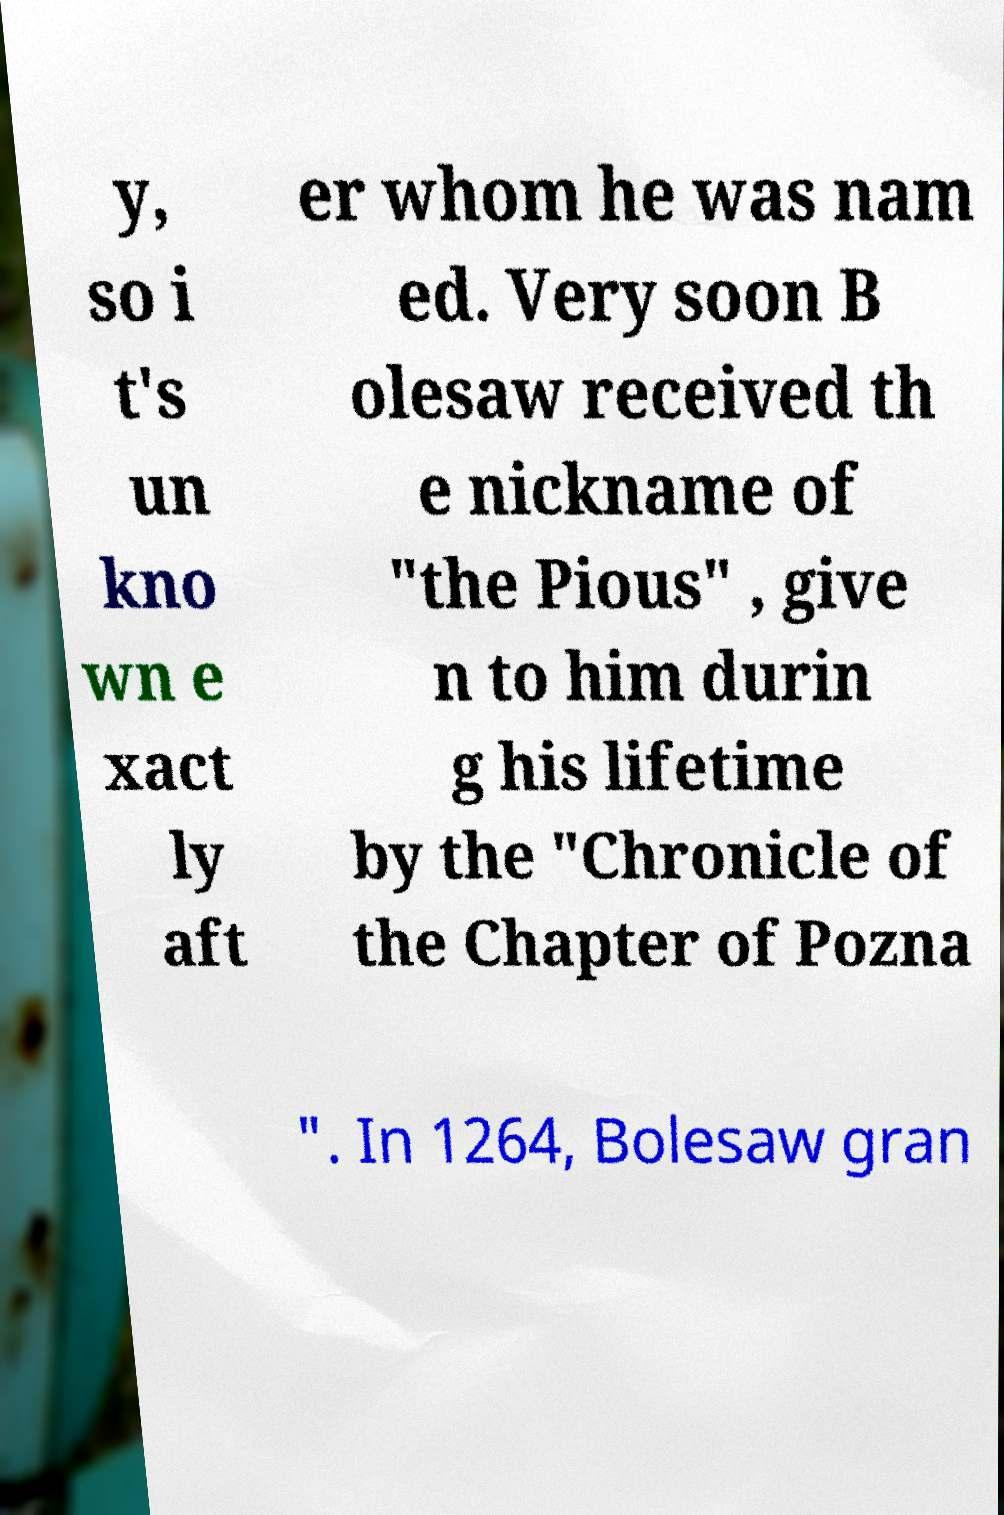Please identify and transcribe the text found in this image. y, so i t's un kno wn e xact ly aft er whom he was nam ed. Very soon B olesaw received th e nickname of "the Pious" , give n to him durin g his lifetime by the "Chronicle of the Chapter of Pozna ". In 1264, Bolesaw gran 